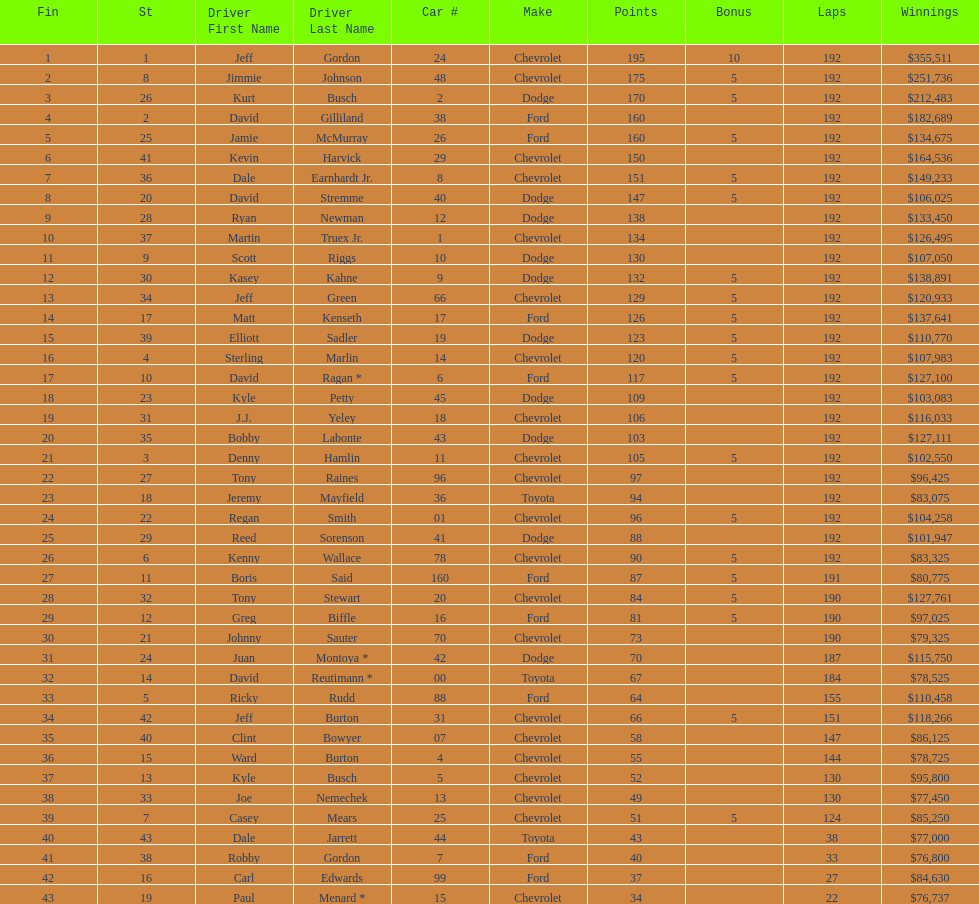Who is first in number of winnings on this list? Jeff Gordon. 